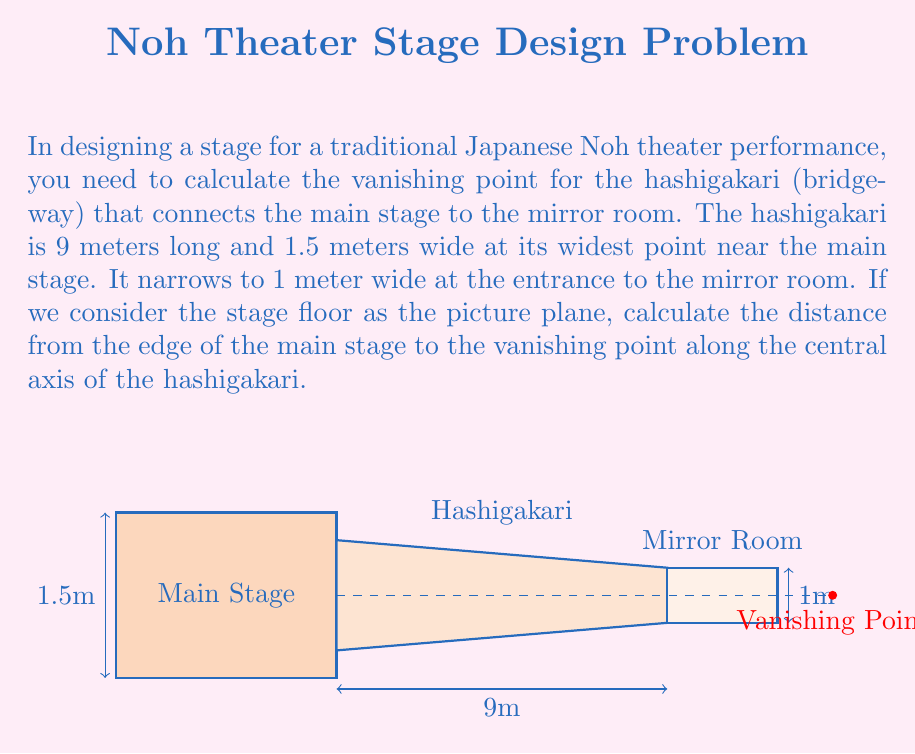What is the answer to this math problem? Let's approach this step-by-step:

1) In perspective drawing, parallel lines converge at a vanishing point. The sides of the hashigakari are parallel in reality but appear to converge in our view.

2) We can use the principle of similar triangles to solve this problem. Let's define our variables:
   $w_1 = 1.5$ m (width at the main stage)
   $w_2 = 1$ m (width at the mirror room)
   $l = 9$ m (length of the hashigakari)
   $x$ = distance to the vanishing point from the main stage

3) The ratio of the difference in widths to the total width is equal to the ratio of the hashigakari length to the total distance to the vanishing point:

   $$\frac{w_1 - w_2}{w_1} = \frac{l}{x}$$

4) Substituting our known values:

   $$\frac{1.5 - 1}{1.5} = \frac{9}{x}$$

5) Simplify:

   $$\frac{0.5}{1.5} = \frac{9}{x}$$

6) Cross multiply:

   $$0.5x = 1.5 * 9$$

7) Solve for x:

   $$x = \frac{1.5 * 9}{0.5} = 27$$

Therefore, the vanishing point is 27 meters from the edge of the main stage along the central axis of the hashigakari.
Answer: 27 meters 